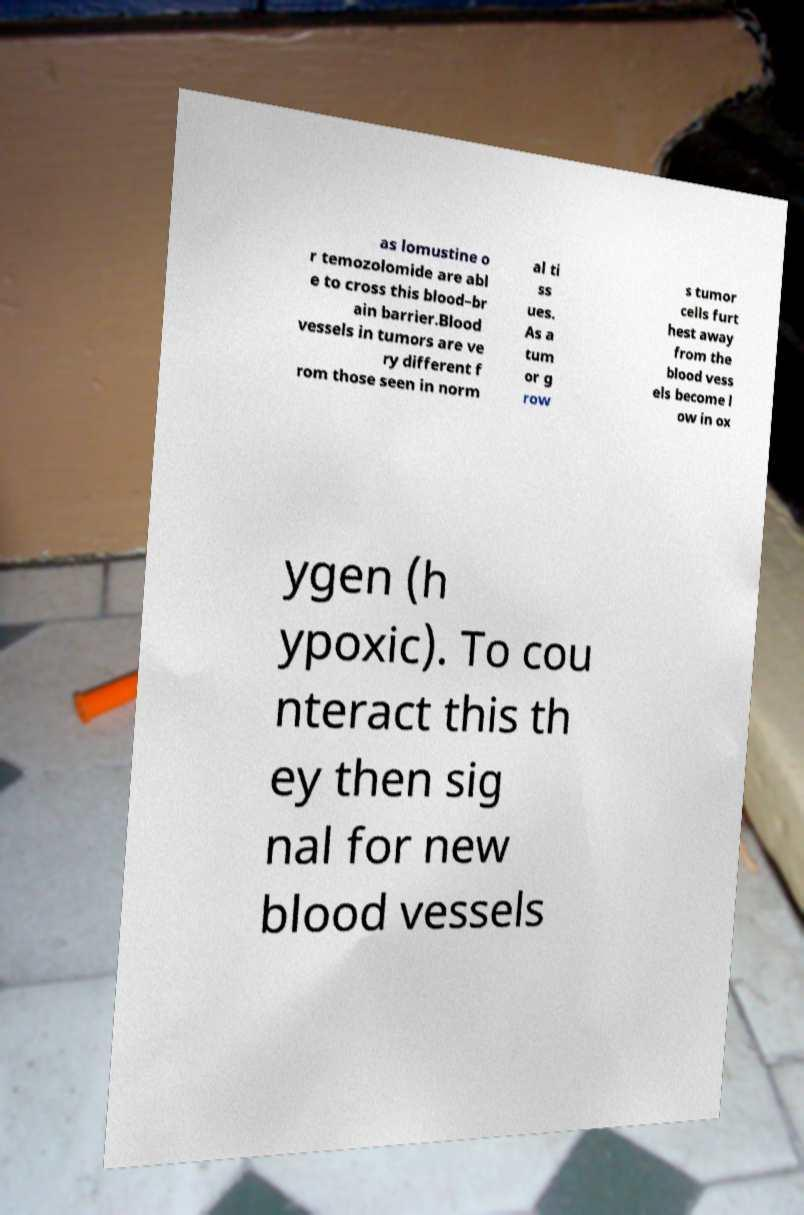Please read and relay the text visible in this image. What does it say? as lomustine o r temozolomide are abl e to cross this blood–br ain barrier.Blood vessels in tumors are ve ry different f rom those seen in norm al ti ss ues. As a tum or g row s tumor cells furt hest away from the blood vess els become l ow in ox ygen (h ypoxic). To cou nteract this th ey then sig nal for new blood vessels 